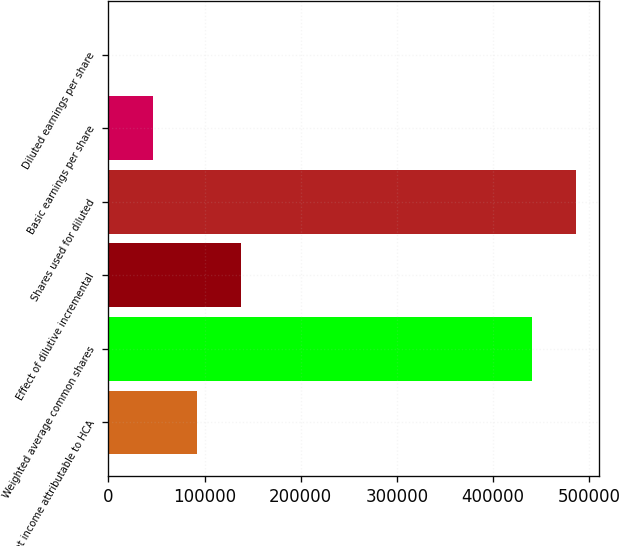Convert chart to OTSL. <chart><loc_0><loc_0><loc_500><loc_500><bar_chart><fcel>Net income attributable to HCA<fcel>Weighted average common shares<fcel>Effect of dilutive incremental<fcel>Shares used for diluted<fcel>Basic earnings per share<fcel>Diluted earnings per share<nl><fcel>91883.4<fcel>440178<fcel>137823<fcel>486118<fcel>45943.4<fcel>3.49<nl></chart> 